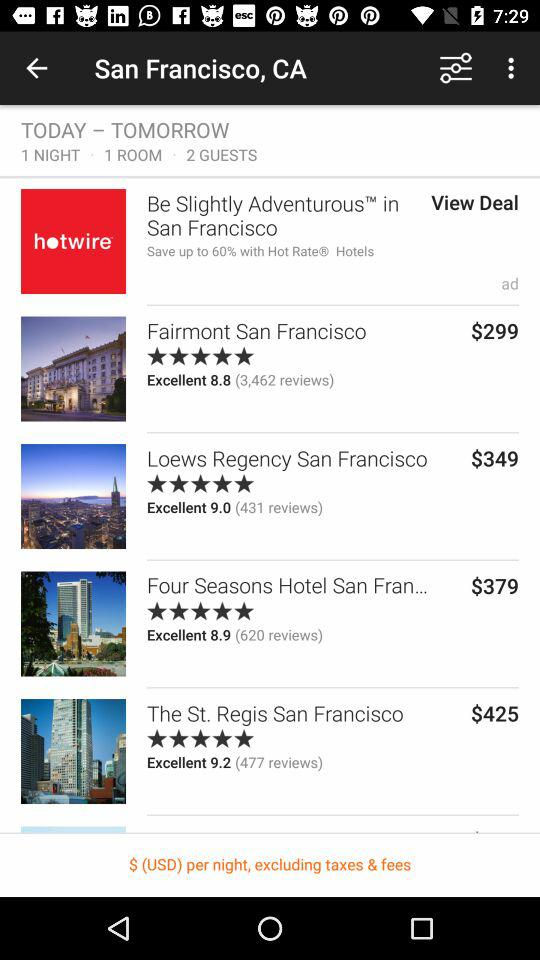How many total guests are there for the booking? There are 2 guests for the booking. 